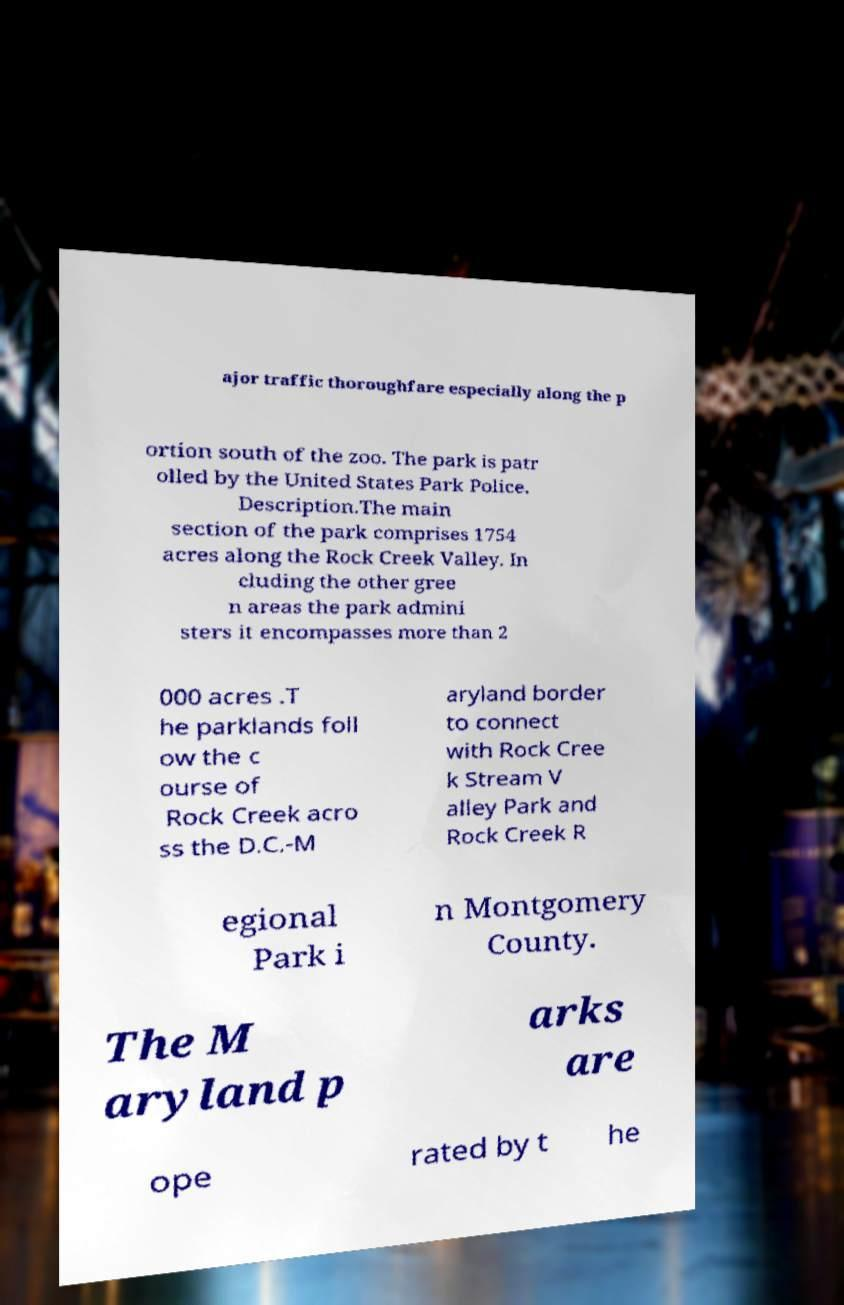Can you accurately transcribe the text from the provided image for me? ajor traffic thoroughfare especially along the p ortion south of the zoo. The park is patr olled by the United States Park Police. Description.The main section of the park comprises 1754 acres along the Rock Creek Valley. In cluding the other gree n areas the park admini sters it encompasses more than 2 000 acres .T he parklands foll ow the c ourse of Rock Creek acro ss the D.C.-M aryland border to connect with Rock Cree k Stream V alley Park and Rock Creek R egional Park i n Montgomery County. The M aryland p arks are ope rated by t he 